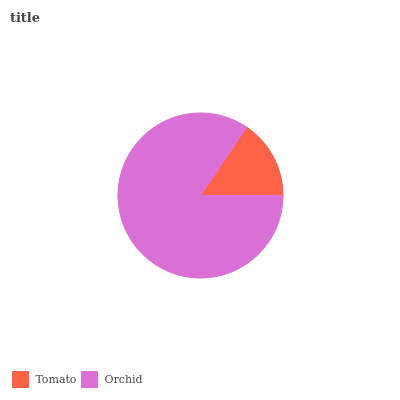Is Tomato the minimum?
Answer yes or no. Yes. Is Orchid the maximum?
Answer yes or no. Yes. Is Orchid the minimum?
Answer yes or no. No. Is Orchid greater than Tomato?
Answer yes or no. Yes. Is Tomato less than Orchid?
Answer yes or no. Yes. Is Tomato greater than Orchid?
Answer yes or no. No. Is Orchid less than Tomato?
Answer yes or no. No. Is Orchid the high median?
Answer yes or no. Yes. Is Tomato the low median?
Answer yes or no. Yes. Is Tomato the high median?
Answer yes or no. No. Is Orchid the low median?
Answer yes or no. No. 